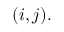<formula> <loc_0><loc_0><loc_500><loc_500>( i , j ) .</formula> 